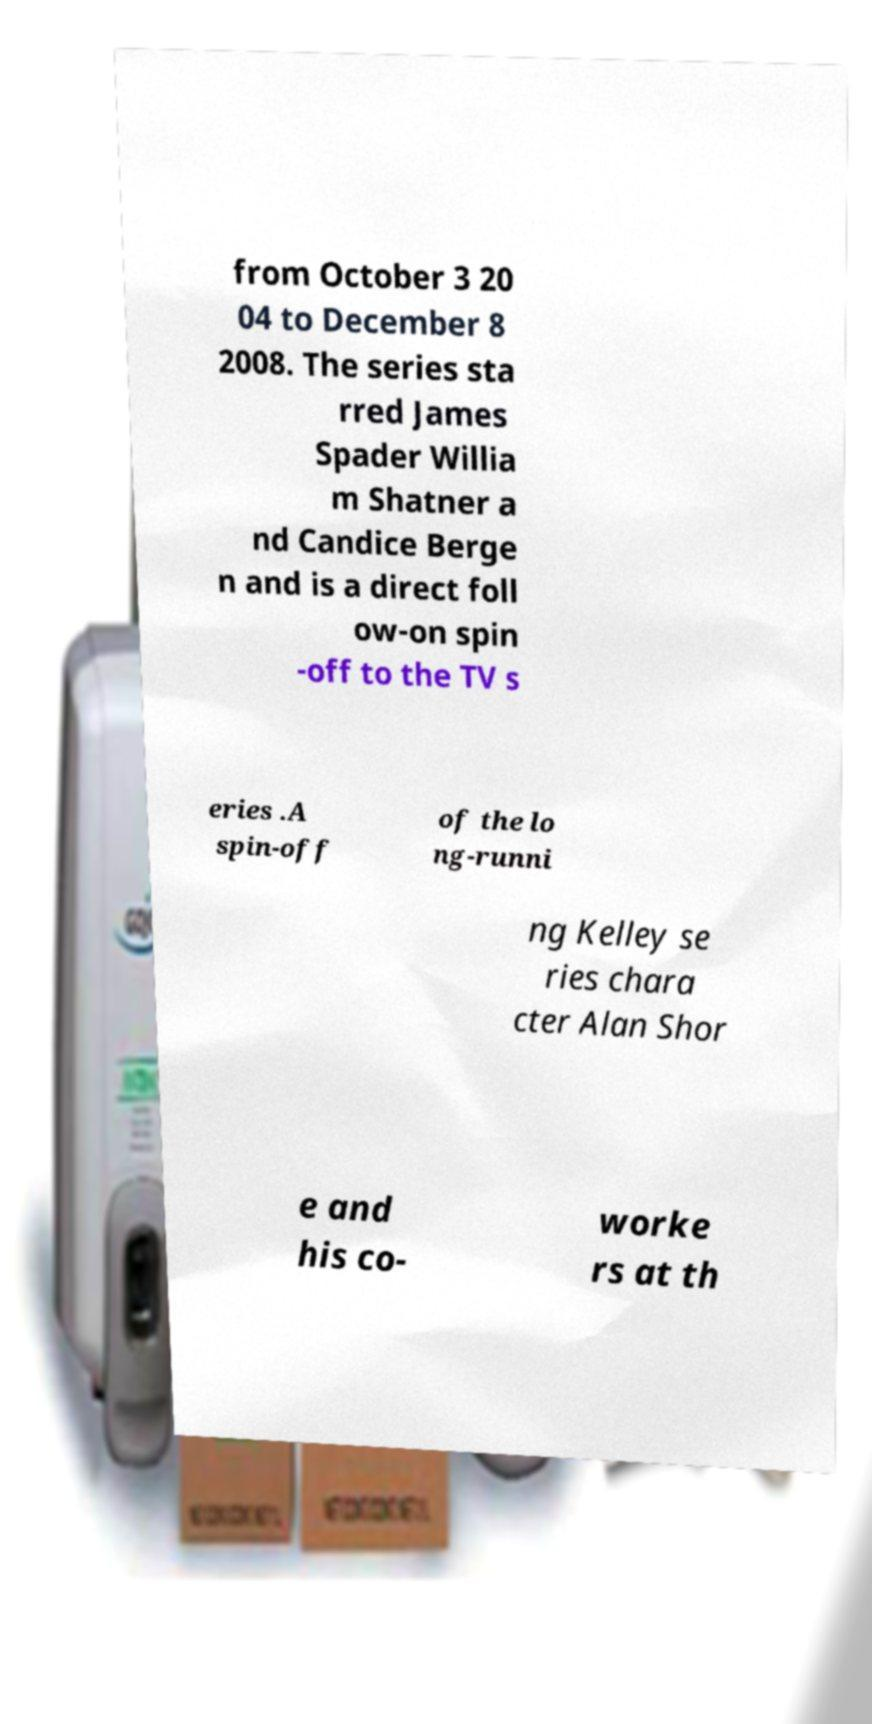Please read and relay the text visible in this image. What does it say? from October 3 20 04 to December 8 2008. The series sta rred James Spader Willia m Shatner a nd Candice Berge n and is a direct foll ow-on spin -off to the TV s eries .A spin-off of the lo ng-runni ng Kelley se ries chara cter Alan Shor e and his co- worke rs at th 